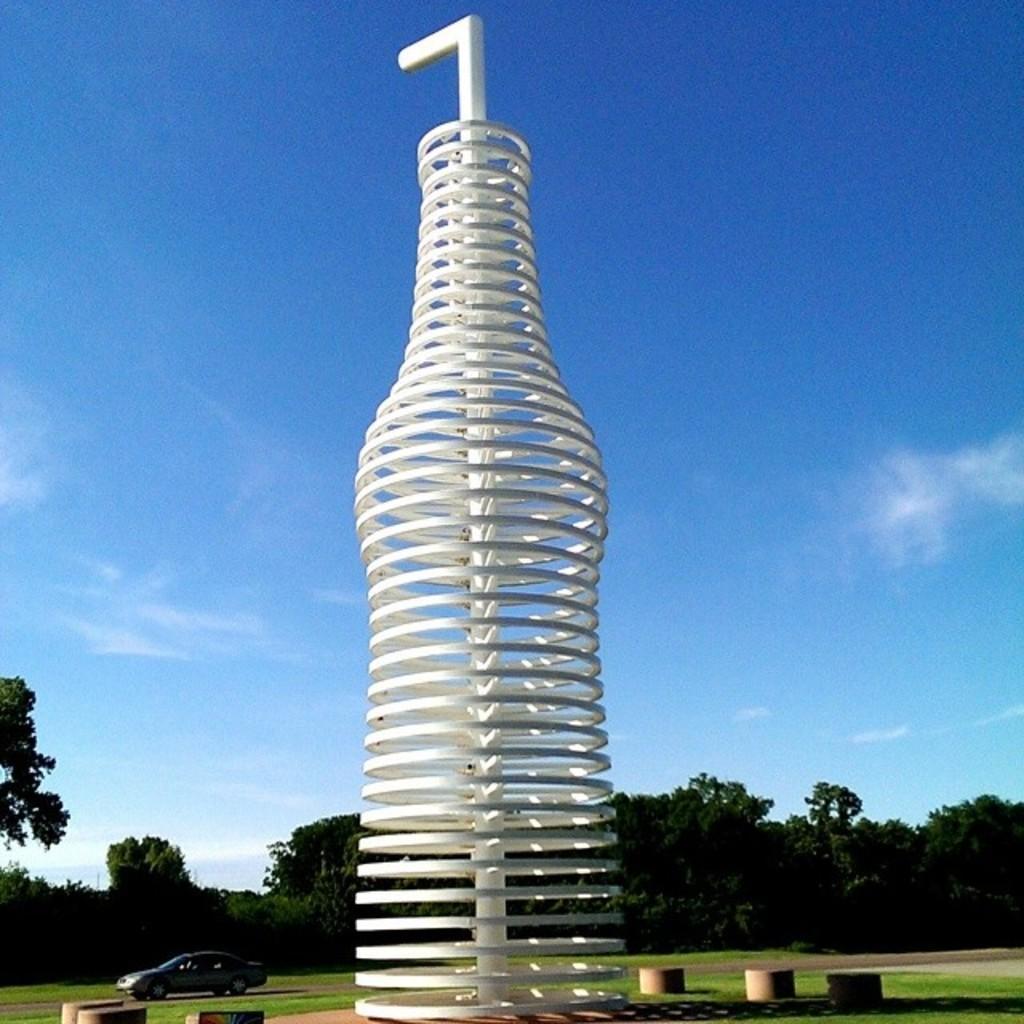In one or two sentences, can you explain what this image depicts? In this image I can see the white color structure. Background I can see the vehicle, trees in green color and the sky is in blue and white color. 